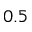Convert formula to latex. <formula><loc_0><loc_0><loc_500><loc_500>0 . 5</formula> 